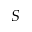<formula> <loc_0><loc_0><loc_500><loc_500>S</formula> 